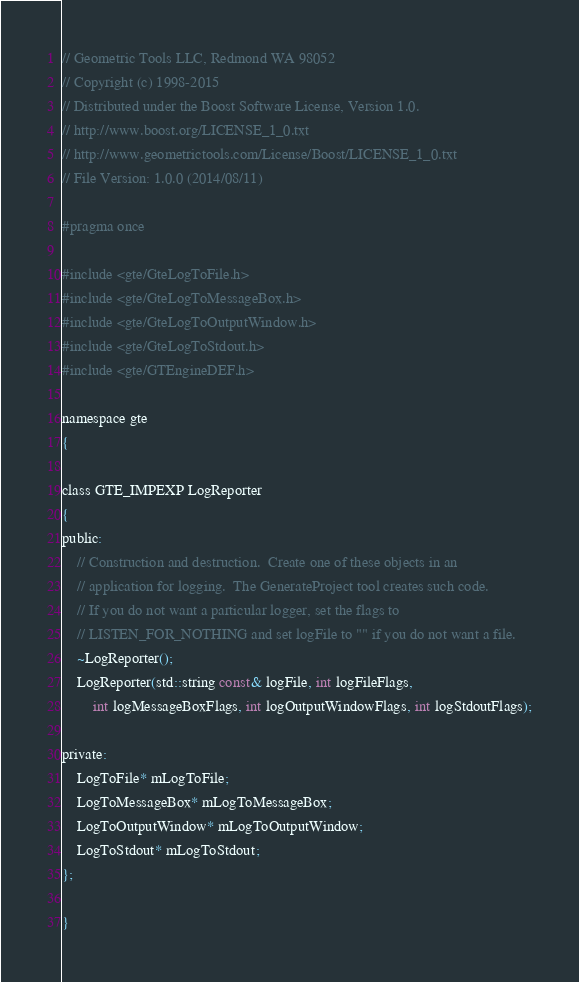Convert code to text. <code><loc_0><loc_0><loc_500><loc_500><_C_>// Geometric Tools LLC, Redmond WA 98052
// Copyright (c) 1998-2015
// Distributed under the Boost Software License, Version 1.0.
// http://www.boost.org/LICENSE_1_0.txt
// http://www.geometrictools.com/License/Boost/LICENSE_1_0.txt
// File Version: 1.0.0 (2014/08/11)

#pragma once

#include <gte/GteLogToFile.h>
#include <gte/GteLogToMessageBox.h>
#include <gte/GteLogToOutputWindow.h>
#include <gte/GteLogToStdout.h>
#include <gte/GTEngineDEF.h>

namespace gte
{

class GTE_IMPEXP LogReporter
{
public:
    // Construction and destruction.  Create one of these objects in an
    // application for logging.  The GenerateProject tool creates such code.
    // If you do not want a particular logger, set the flags to
    // LISTEN_FOR_NOTHING and set logFile to "" if you do not want a file.
    ~LogReporter();
    LogReporter(std::string const& logFile, int logFileFlags,
        int logMessageBoxFlags, int logOutputWindowFlags, int logStdoutFlags);

private:
    LogToFile* mLogToFile;
    LogToMessageBox* mLogToMessageBox;
    LogToOutputWindow* mLogToOutputWindow;
    LogToStdout* mLogToStdout;
};

}
</code> 